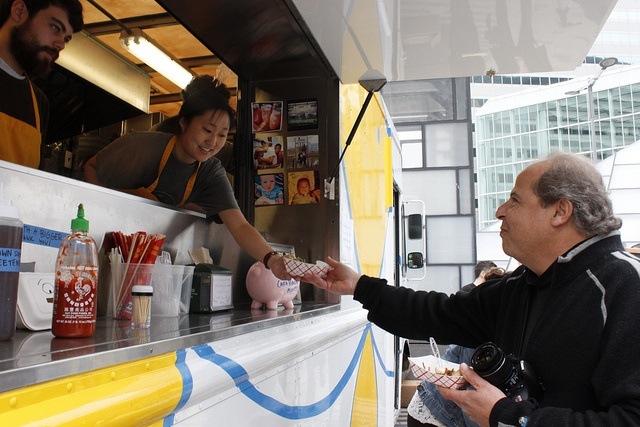Describe the objects in this image and their specific colors. I can see truck in black, lightgray, darkgray, and khaki tones, people in black, brown, gray, and lightgray tones, people in black, maroon, and gray tones, people in black and maroon tones, and bottle in black, maroon, darkgray, and gray tones in this image. 